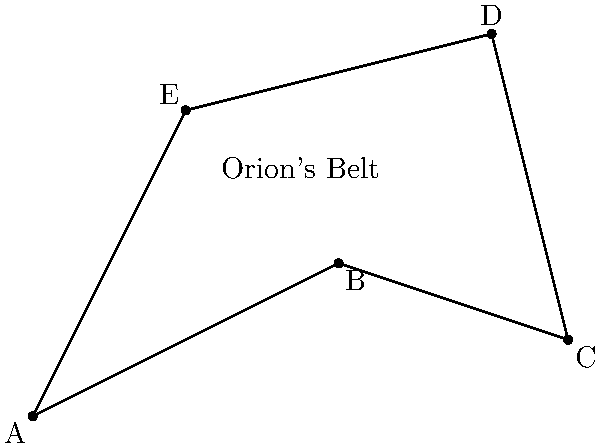In a creative project to blend astronomy with mathematics, you've been tasked with calculating the area of an irregular polygon formed by connecting five stars in the constellation Orion. The stars' positions on a coordinate plane are given as A(0,0), B(4,2), C(7,1), D(6,5), and E(2,4). Calculate the area of this polygon using coordinate geometry methods. Round your answer to the nearest square unit. To calculate the area of this irregular polygon, we can use the Shoelace formula (also known as the surveyor's formula). This method is both scientifically accurate and creatively engaging, perfect for our persona.

Step 1: Arrange the coordinates in order (either clockwise or counterclockwise).
We have: (0,0), (4,2), (7,1), (6,5), (2,4)

Step 2: Apply the Shoelace formula:
Area = $\frac{1}{2}|((x_1y_2 + x_2y_3 + ... + x_ny_1) - (y_1x_2 + y_2x_3 + ... + y_nx_1))|$

Where $(x_i, y_i)$ are the coordinates of each point.

Step 3: Substitute the values:
Area = $\frac{1}{2}|((0 \cdot 2 + 4 \cdot 1 + 7 \cdot 5 + 6 \cdot 4 + 2 \cdot 0) - (0 \cdot 4 + 2 \cdot 7 + 1 \cdot 6 + 5 \cdot 2 + 4 \cdot 0))|$

Step 4: Calculate:
Area = $\frac{1}{2}|((0 + 4 + 35 + 24 + 0) - (0 + 14 + 6 + 10 + 0))|$
    = $\frac{1}{2}|(63 - 30)|$
    = $\frac{1}{2}(33)$
    = 16.5

Step 5: Round to the nearest square unit:
Area ≈ 17 square units
Answer: 17 square units 